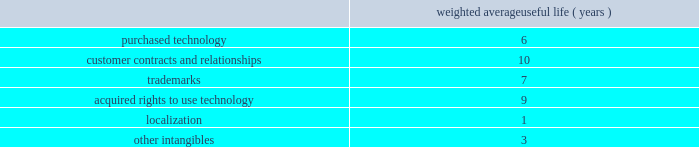Improvements are amortized using the straight-line method over the lesser of the remaining respective lease term or estimated useful lives ranging from 1 to 15 years .
Goodwill , purchased intangibles and other long-lived assets we review our goodwill for impairment annually , or more frequently , if facts and circumstances warrant a review .
We completed our annual impairment test in the second quarter of fiscal 2011 and determined that there was no impairment .
In the fourth quarter of fiscal 2011 , we announced changes to our business strategy which resulted in a reduction of forecasted revenue for certain of our products .
We performed an update to our goodwill impairment test for the enterprise reporting unit and determined there was no impairment .
Goodwill is assigned to one or more reporting segments on the date of acquisition .
We evaluate goodwill for impairment by comparing the fair value of each of our reporting segments to its carrying value , including the associated goodwill .
To determine the fair values , we use the market approach based on comparable publicly traded companies in similar lines of businesses and the income approach based on estimated discounted future cash flows .
Our cash flow assumptions consider historical and forecasted revenue , operating costs and other relevant factors .
We amortize intangible assets with finite lives over their estimated useful lives and review them for impairment whenever an impairment indicator exists .
We continually monitor events and changes in circumstances that could indicate carrying amounts of our long-lived assets , including our intangible assets may not be recoverable .
When such events or changes in circumstances occur , we assess recoverability by determining whether the carrying value of such assets will be recovered through the undiscounted expected future cash flows .
If the future undiscounted cash flows are less than the carrying amount of these assets , we recognize an impairment loss based on any excess of the carrying amount over the fair value of the assets .
We did not recognize any intangible asset impairment charges in fiscal 2011 , 2010 or 2009 .
Our intangible assets are amortized over their estimated useful lives of 1 to 13 years .
Amortization is based on the pattern in which the economic benefits of the intangible asset will be consumed .
The weighted average useful lives of our intangibles assets was as follows: .
Weighted average useful life ( years ) software development costs capitalization of software development costs for software to be sold , leased , or otherwise marketed begins upon the establishment of technological feasibility , which is generally the completion of a working prototype that has been certified as having no critical bugs and is a release candidate .
Amortization begins once the software is ready for its intended use , generally based on the pattern in which the economic benefits will be consumed .
To date , software development costs incurred between completion of a working prototype and general availability of the related product have not been material .
Internal use software we capitalize costs associated with customized internal-use software systems that have reached the application development stage .
Such capitalized costs include external direct costs utilized in developing or obtaining the applications and payroll and payroll-related expenses for employees , who are directly associated with the development of the applications .
Capitalization of such costs begins when the preliminary project stage is complete and ceases at the point in which the project is substantially complete and is ready for its intended purpose .
Table of contents adobe systems incorporated notes to consolidated financial statements ( continued ) .
What was average weighted average useful life ( years ) for customer contracts and relationships and trademarks? 
Computations: ((10 + 7) / 2)
Answer: 8.5. 